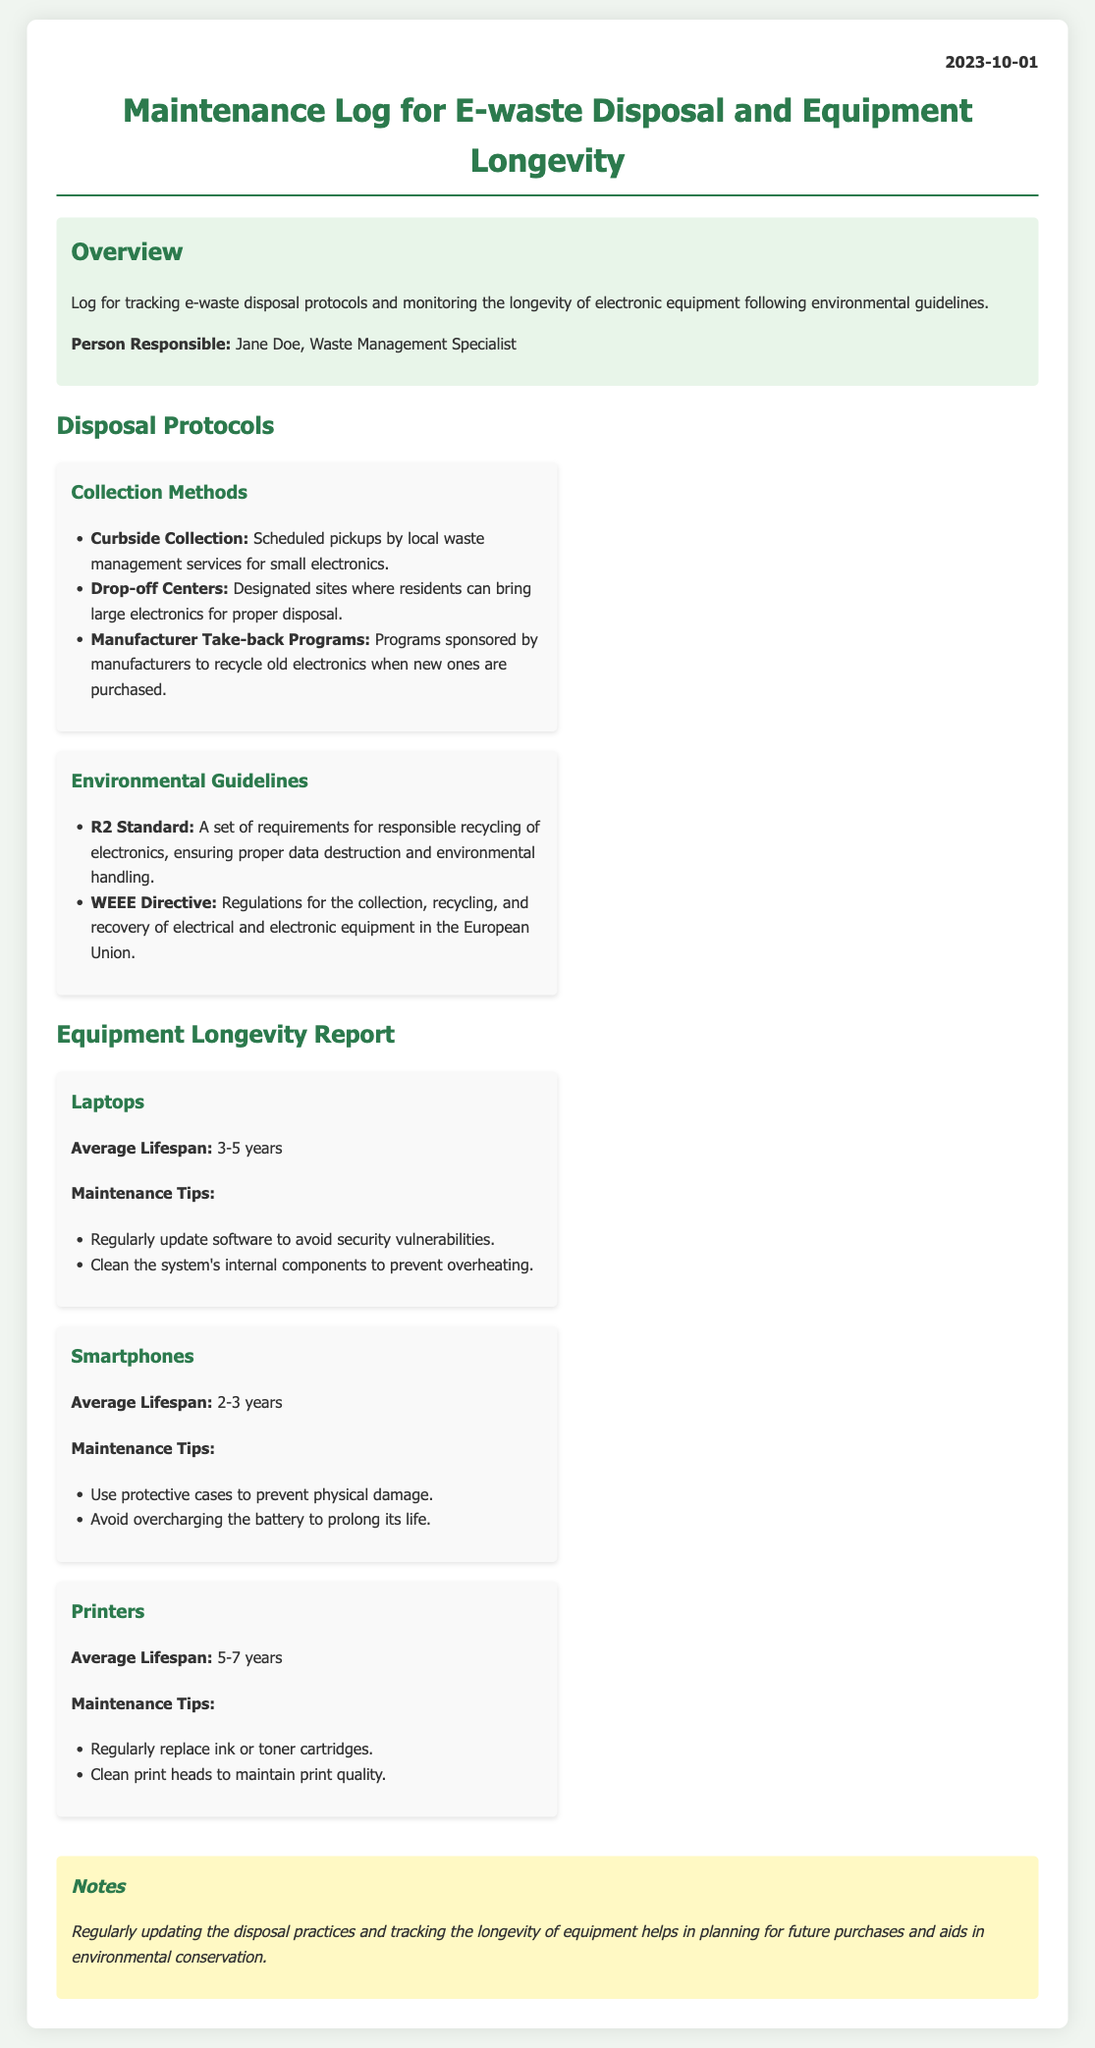What is the date of the log? The date of the log is mentioned at the top of the document.
Answer: 2023-10-01 Who is responsible for the log? The name of the person responsible is provided in the overview section of the document.
Answer: Jane Doe What is the average lifespan of laptops? The lifespan is listed in the Equipment Longevity Report section of the document.
Answer: 3-5 years What standard is mentioned for responsible recycling? The document includes standards related to e-waste recycling in the Disposal Protocols section.
Answer: R2 Standard What are the maintenance tips for smartphones? Maintenance tips are listed under each category in the Equipment Longevity Report.
Answer: Use protective cases to prevent physical damage; avoid overcharging the battery to prolong its life How long is the average lifespan of printers? The lifespan for printers is provided under the Equipment Longevity Report section in the document.
Answer: 5-7 years What are two types of collection methods mentioned? The document lists specific methods in the Disposal Protocols section.
Answer: Curbside Collection; Drop-off Centers What is the WEEE Directive? The document describes this regulation in the context of e-waste disposal.
Answer: Regulations for the collection, recycling, and recovery of electrical and electronic equipment in the European Union What is the main purpose of the log? The purpose is summarized in the overview section of the document.
Answer: Tracking e-waste disposal protocols and monitoring the longevity of electronic equipment 